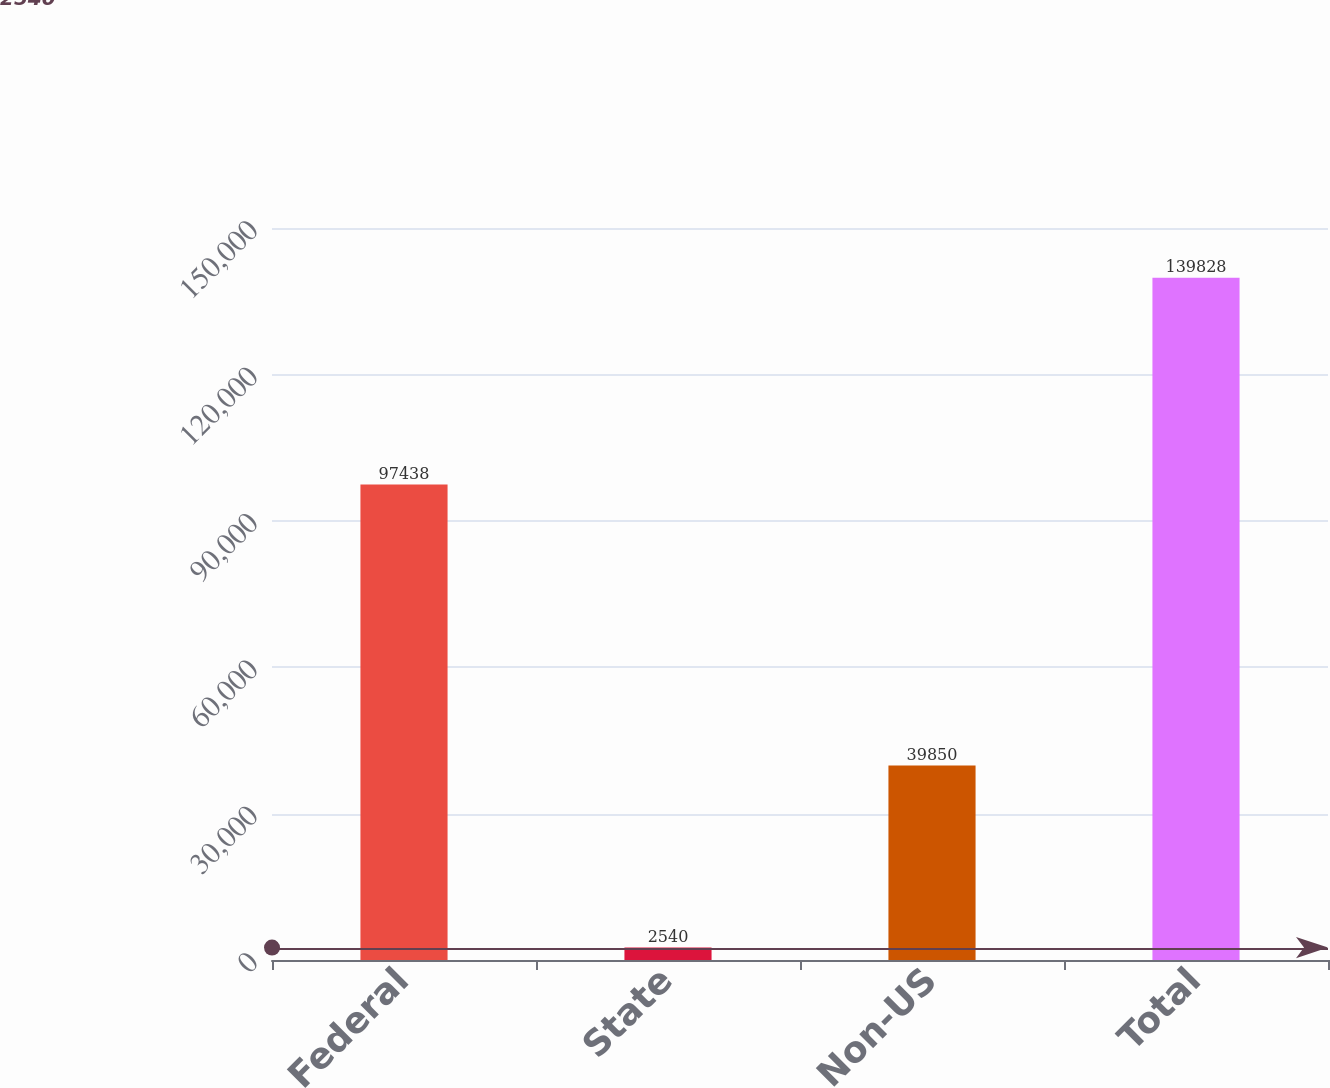<chart> <loc_0><loc_0><loc_500><loc_500><bar_chart><fcel>Federal<fcel>State<fcel>Non-US<fcel>Total<nl><fcel>97438<fcel>2540<fcel>39850<fcel>139828<nl></chart> 